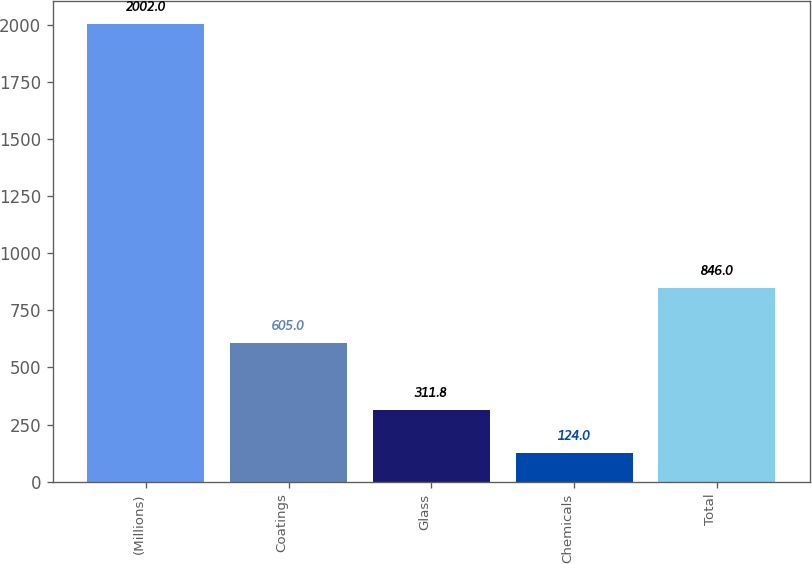Convert chart. <chart><loc_0><loc_0><loc_500><loc_500><bar_chart><fcel>(Millions)<fcel>Coatings<fcel>Glass<fcel>Chemicals<fcel>Total<nl><fcel>2002<fcel>605<fcel>311.8<fcel>124<fcel>846<nl></chart> 